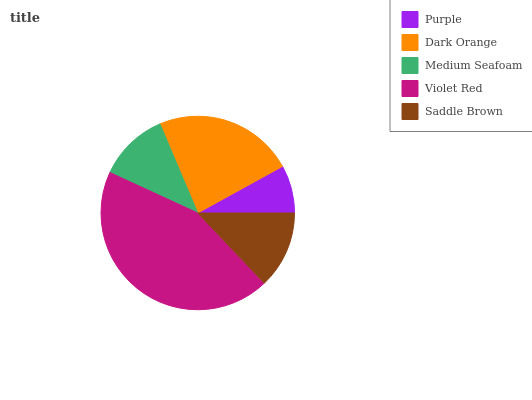Is Purple the minimum?
Answer yes or no. Yes. Is Violet Red the maximum?
Answer yes or no. Yes. Is Dark Orange the minimum?
Answer yes or no. No. Is Dark Orange the maximum?
Answer yes or no. No. Is Dark Orange greater than Purple?
Answer yes or no. Yes. Is Purple less than Dark Orange?
Answer yes or no. Yes. Is Purple greater than Dark Orange?
Answer yes or no. No. Is Dark Orange less than Purple?
Answer yes or no. No. Is Saddle Brown the high median?
Answer yes or no. Yes. Is Saddle Brown the low median?
Answer yes or no. Yes. Is Medium Seafoam the high median?
Answer yes or no. No. Is Medium Seafoam the low median?
Answer yes or no. No. 